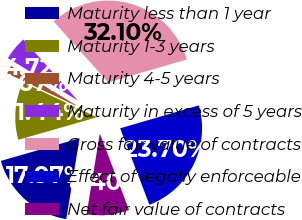<chart> <loc_0><loc_0><loc_500><loc_500><pie_chart><fcel>Maturity less than 1 year<fcel>Maturity 1-3 years<fcel>Maturity 4-5 years<fcel>Maturity in excess of 5 years<fcel>Gross fair value of contracts<fcel>Effect of legally enforceable<fcel>Net fair value of contracts<nl><fcel>17.97%<fcel>11.44%<fcel>1.67%<fcel>4.72%<fcel>32.1%<fcel>23.7%<fcel>8.4%<nl></chart> 